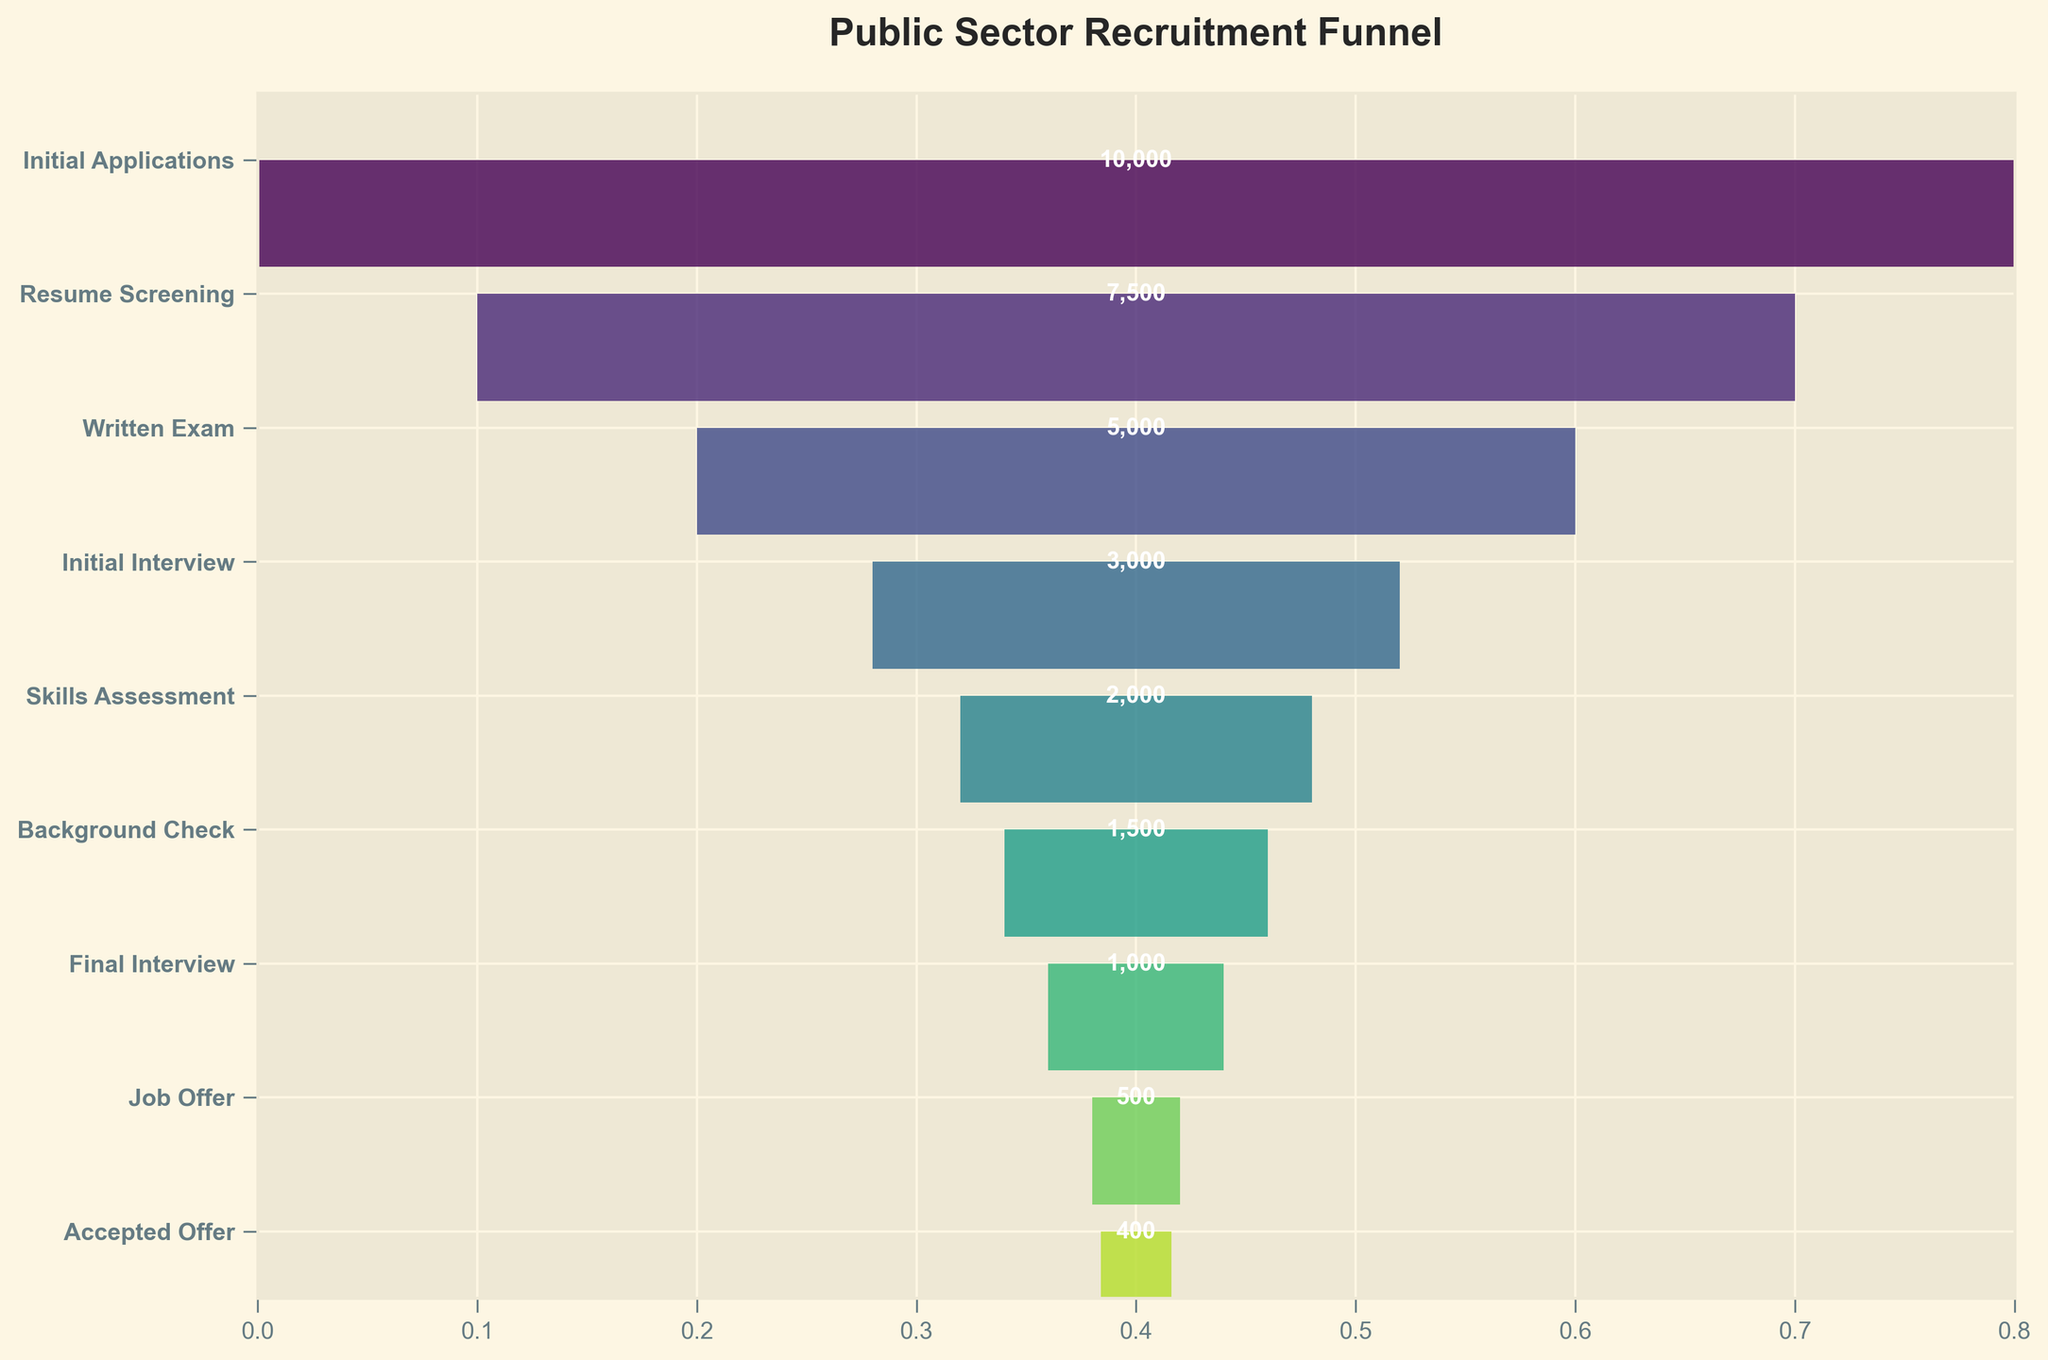What is the title of the funnel chart? The title of the chart is written at the top and usually summarizes the entire visualization.
Answer: Public Sector Recruitment Funnel What is the total number of applicants who accepted the job offer? Look at the last bar in the funnel chart and find the label inside it. The value indicates the number of applicants who accepted the job offer.
Answer: 400 By how many applicants did the number decrease from the Initial Interview stage to the Final Interview stage? Subtract the number of applicants at the Final Interview stage from the number of applicants at the Initial Interview stage: 3000 - 1000 = 2000.
Answer: 2000 Which stage sees the largest drop in the number of applicants compared to the previous stage? Compare the number of applicants at each stage with the preceding stage to identify the largest drop. The drop from Initial Applications (10000) to Resume Screening (7500) is 2500.
Answer: Initial Applications to Resume Screening What percentage of initial applicants received a job offer? Divide the number of job offers by the number of initial applications and multiply by 100: (500 / 10000) * 100 = 5%.
Answer: 5% Are there more applicants in the Skills Assessment stage or the Background Check stage? Compare the number of applicants in the Skills Assessment stage (2000) with those in the Background Check stage (1500).
Answer: Skills Assessment stage How many applicants were there after the Written Exam stage? Locate the Written Exam stage in the chart and note the number of applicants inside the respective bar.
Answer: 5000 What is the second stage with exactly half the number of applicants of the previous stage? Identify stages where applicants are halved relative to the previous stage: Final Interview (1000) compared to Background Check (1500) does not halve, but Job Offer (500) is exactly half of Final Interview (1000).
Answer: Job Offer What cumulative percentage does the Initial Interview account for when considering the total initial applications? Calculate the percentage of applicants at the Initial Interview stage: (3000 / 10000) * 100 = 30%.
Answer: 30% Is the acceptance rate higher or lower than 50% for those who received job offers? Calculate the acceptance rate by dividing the number of accepted offers by the number of job offers and comparing it to 50%: (400 / 500) = 80%, which is higher than 50%.
Answer: Higher 